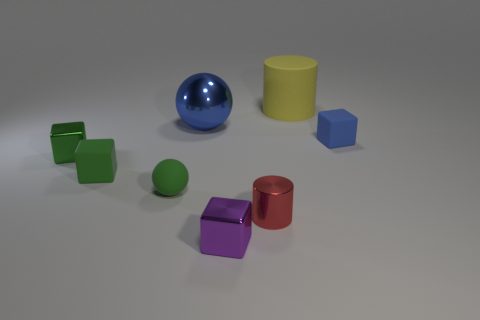There is a big blue ball; how many tiny green matte balls are in front of it?
Provide a short and direct response. 1. Are there an equal number of small metal blocks to the left of the large blue metallic sphere and small red metallic cylinders?
Keep it short and to the point. Yes. What number of things are large blue balls or small objects?
Ensure brevity in your answer.  7. Is there any other thing that is the same shape as the big yellow thing?
Give a very brief answer. Yes. What is the shape of the large object to the left of the tiny metallic cube that is in front of the small green ball?
Provide a short and direct response. Sphere. There is a large blue thing that is made of the same material as the tiny cylinder; what shape is it?
Offer a terse response. Sphere. There is a blue thing left of the tiny shiny block in front of the green shiny object; how big is it?
Provide a short and direct response. Large. What is the shape of the red shiny object?
Give a very brief answer. Cylinder. How many tiny things are yellow things or balls?
Keep it short and to the point. 1. What is the size of the green metal thing that is the same shape as the tiny blue rubber thing?
Provide a short and direct response. Small. 